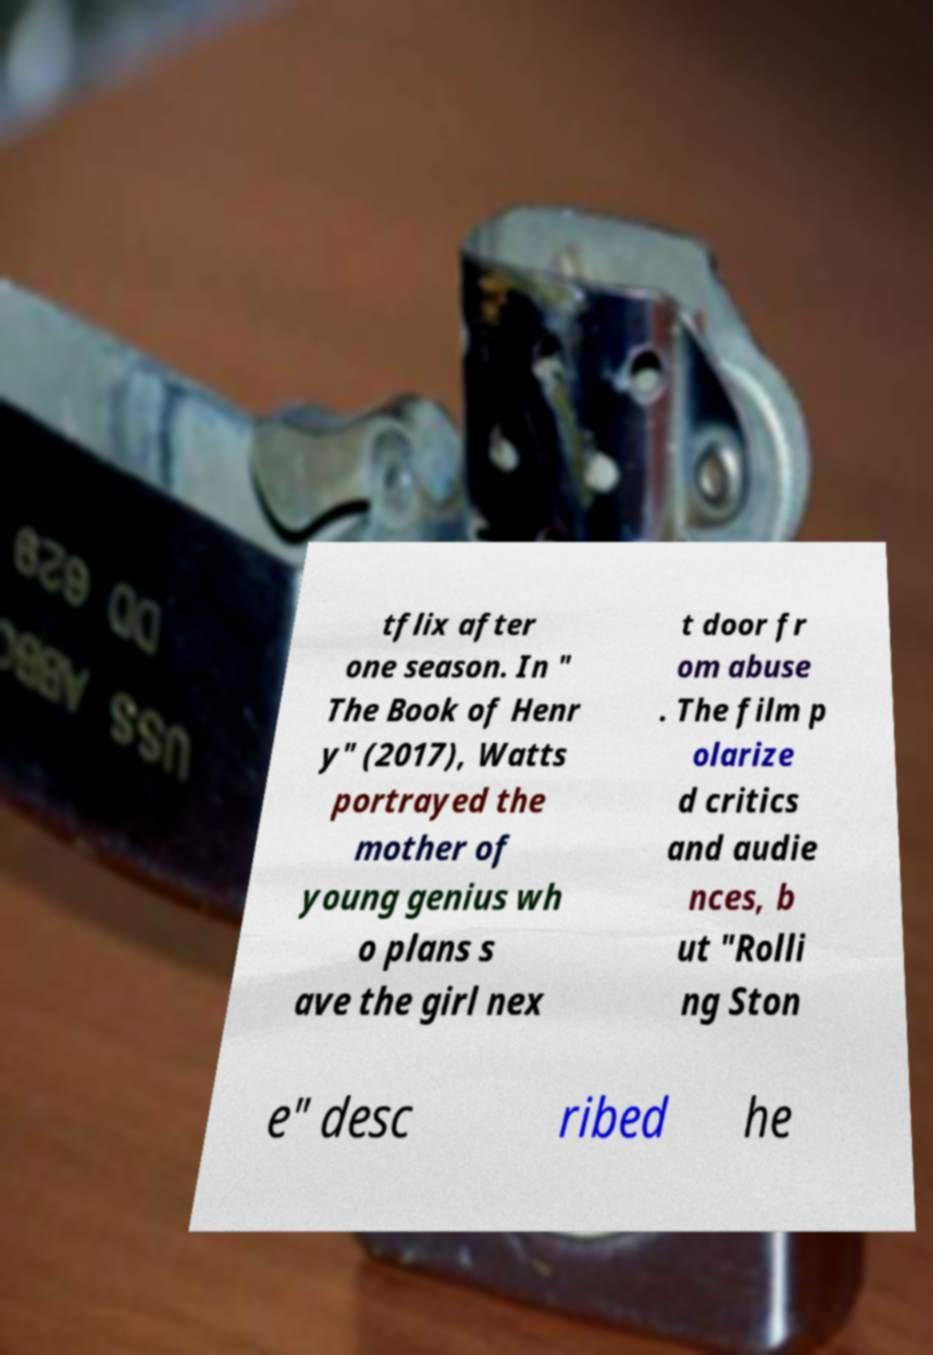What messages or text are displayed in this image? I need them in a readable, typed format. tflix after one season. In " The Book of Henr y" (2017), Watts portrayed the mother of young genius wh o plans s ave the girl nex t door fr om abuse . The film p olarize d critics and audie nces, b ut "Rolli ng Ston e" desc ribed he 